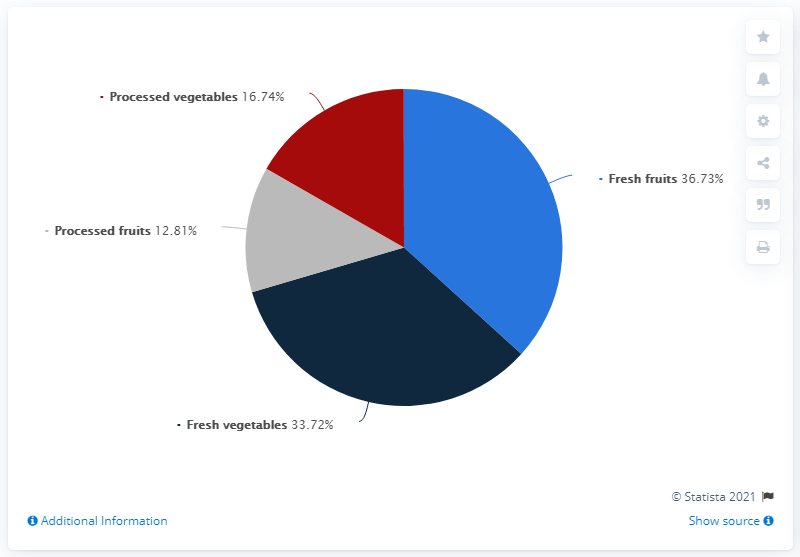Give some essential details in this illustration. In 2019, U.S. households spent 36.73% of their total expenditures on fruits and vegetables. The expenditure on fresh fruits is 36.73%. The difference in expenditure between fresh fruits and processed fruits is 23.92 million. 